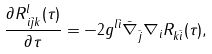<formula> <loc_0><loc_0><loc_500><loc_500>\frac { \partial R ^ { l } _ { \, i \bar { j } k } ( \tau ) } { \partial \tau } = - 2 g ^ { l \bar { i } } \bar { \nabla } _ { \bar { j } } \nabla _ { i } R _ { k \bar { i } } ( \tau ) ,</formula> 